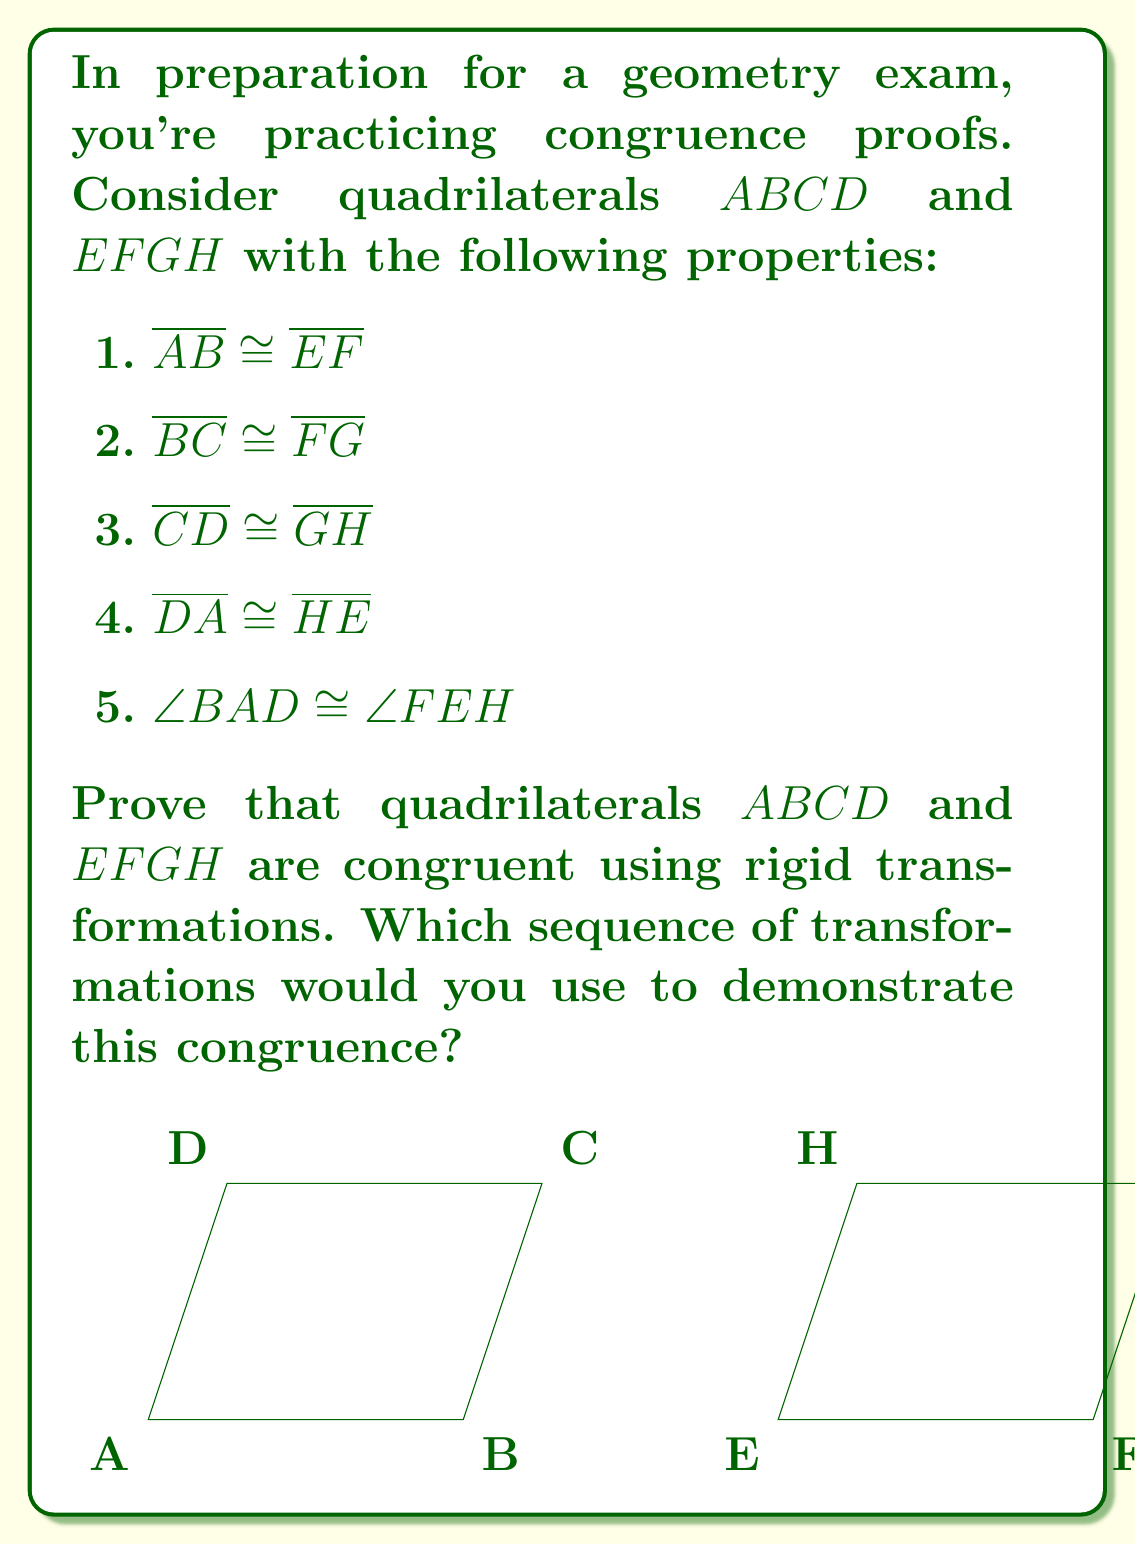Give your solution to this math problem. Let's approach this step-by-step:

1) First, we need to identify which rigid transformations we can use. The options are translation, rotation, and reflection.

2) Given that $\overline{AB} \cong \overline{EF}$, we can start by translating $ABCD$ so that $A$ coincides with $E$ and $B$ coincides with $F$. Let's call this translated quadrilateral $A'B'C'D'$.

3) After translation, we know:
   - $A'$ coincides with $E$
   - $B'$ coincides with $F$
   - $\overline{A'D'} \cong \overline{HE}$ (given)
   - $\angle B'A'D' \cong \angle FEH$ (given)

4) Since $\angle B'A'D' \cong \angle FEH$ and $\overline{A'D'} \cong \overline{HE}$, we can rotate $A'B'C'D'$ around point $E$ until $D'$ coincides with $H$. Let's call this rotated quadrilateral $A''B''C''D''$.

5) After rotation, we have:
   - $A''$ coincides with $E$
   - $B''$ coincides with $F$
   - $D''$ coincides with $H$

6) We're given that $\overline{BC} \cong \overline{FG}$ and $\overline{CD} \cong \overline{GH}$. Since rigid transformations preserve distances and angles, we also know that $\overline{B''C''} \cong \overline{FG}$ and $\overline{C''D''} \cong \overline{GH}$.

7) With three vertices coinciding ($A''$ with $E$, $B''$ with $F$, and $D''$ with $H$) and all corresponding sides congruent, we can conclude that $C''$ must coincide with $G$.

8) Therefore, quadrilateral $A''B''C''D''$ fully coincides with $EFGH$, proving that $ABCD$ and $EFGH$ are congruent.
Answer: Translation followed by rotation 